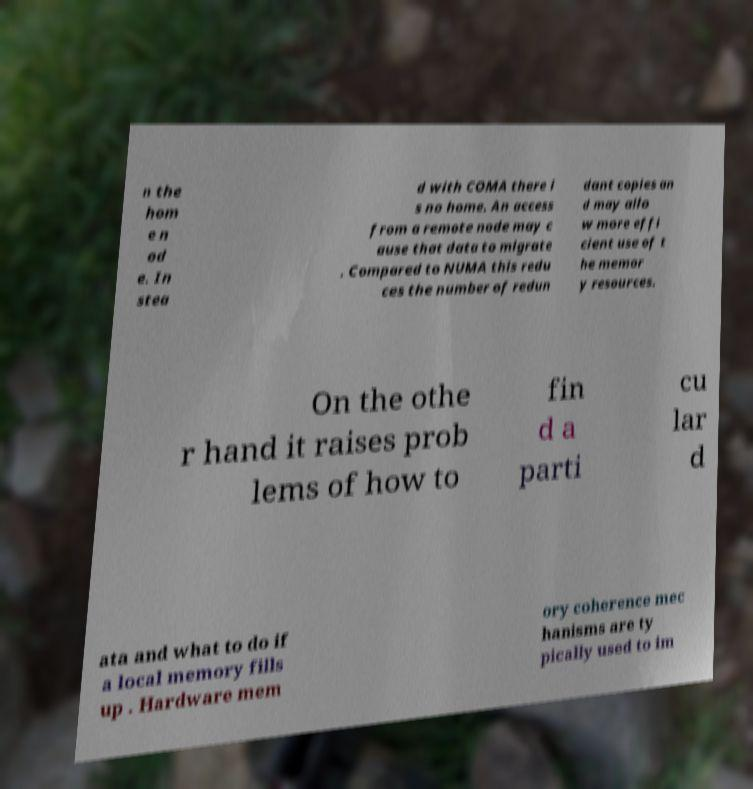There's text embedded in this image that I need extracted. Can you transcribe it verbatim? n the hom e n od e. In stea d with COMA there i s no home. An access from a remote node may c ause that data to migrate . Compared to NUMA this redu ces the number of redun dant copies an d may allo w more effi cient use of t he memor y resources. On the othe r hand it raises prob lems of how to fin d a parti cu lar d ata and what to do if a local memory fills up . Hardware mem ory coherence mec hanisms are ty pically used to im 